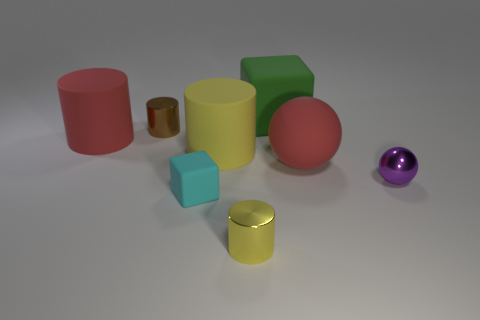Subtract 1 cylinders. How many cylinders are left? 3 Subtract all big yellow cylinders. How many cylinders are left? 3 Add 1 big red cylinders. How many objects exist? 9 Subtract all blocks. How many objects are left? 6 Subtract all green cubes. How many cubes are left? 1 Subtract all gray balls. How many yellow blocks are left? 0 Subtract all cylinders. Subtract all cyan things. How many objects are left? 3 Add 4 big yellow objects. How many big yellow objects are left? 5 Add 2 brown cylinders. How many brown cylinders exist? 3 Subtract 1 red cylinders. How many objects are left? 7 